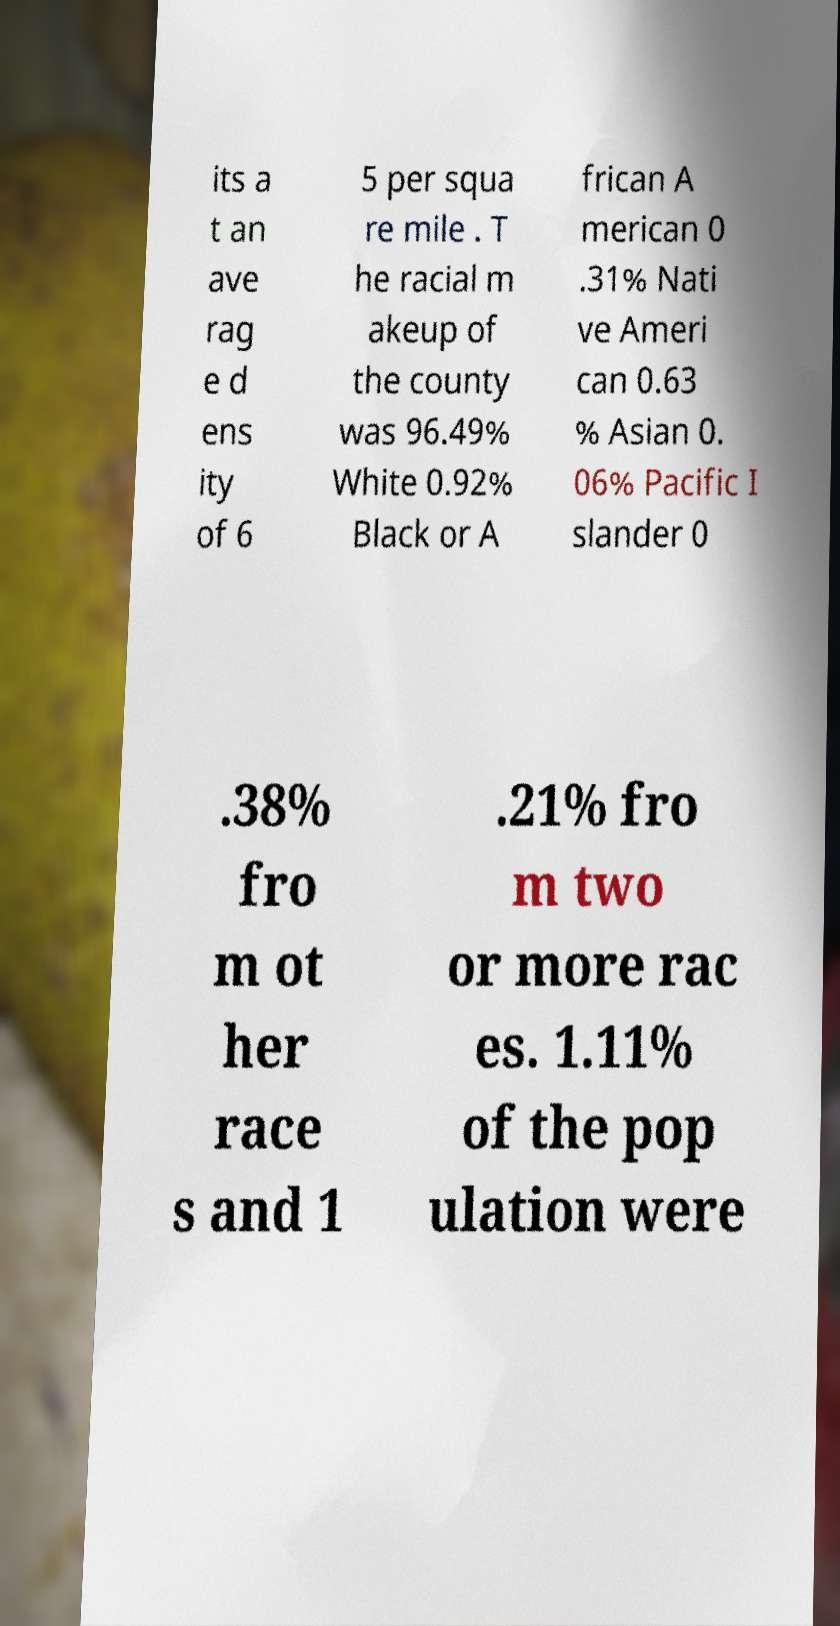Can you read and provide the text displayed in the image?This photo seems to have some interesting text. Can you extract and type it out for me? its a t an ave rag e d ens ity of 6 5 per squa re mile . T he racial m akeup of the county was 96.49% White 0.92% Black or A frican A merican 0 .31% Nati ve Ameri can 0.63 % Asian 0. 06% Pacific I slander 0 .38% fro m ot her race s and 1 .21% fro m two or more rac es. 1.11% of the pop ulation were 